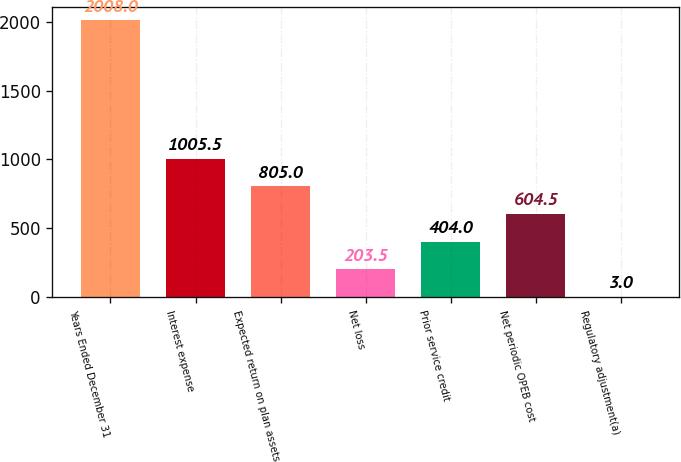Convert chart. <chart><loc_0><loc_0><loc_500><loc_500><bar_chart><fcel>Years Ended December 31<fcel>Interest expense<fcel>Expected return on plan assets<fcel>Net loss<fcel>Prior service credit<fcel>Net periodic OPEB cost<fcel>Regulatory adjustment(a)<nl><fcel>2008<fcel>1005.5<fcel>805<fcel>203.5<fcel>404<fcel>604.5<fcel>3<nl></chart> 